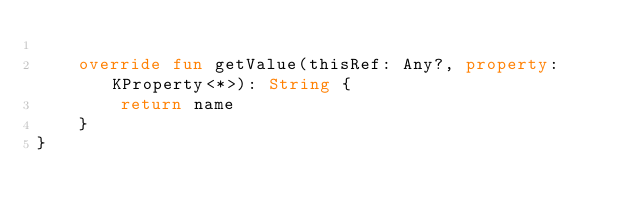<code> <loc_0><loc_0><loc_500><loc_500><_Kotlin_>
    override fun getValue(thisRef: Any?, property: KProperty<*>): String {
        return name
    }
}</code> 